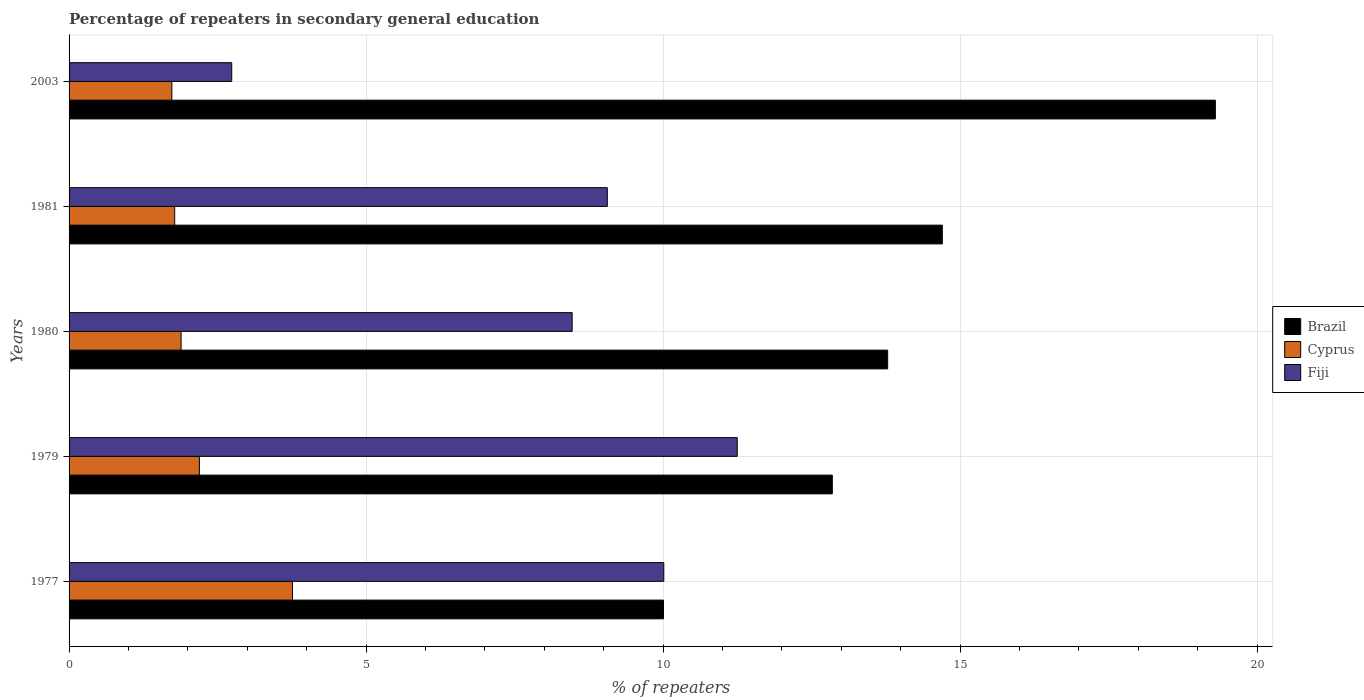Are the number of bars on each tick of the Y-axis equal?
Your response must be concise. Yes. How many bars are there on the 2nd tick from the top?
Keep it short and to the point. 3. How many bars are there on the 1st tick from the bottom?
Offer a very short reply. 3. In how many cases, is the number of bars for a given year not equal to the number of legend labels?
Make the answer very short. 0. What is the percentage of repeaters in secondary general education in Fiji in 1980?
Keep it short and to the point. 8.47. Across all years, what is the maximum percentage of repeaters in secondary general education in Brazil?
Offer a very short reply. 19.3. Across all years, what is the minimum percentage of repeaters in secondary general education in Fiji?
Offer a very short reply. 2.74. In which year was the percentage of repeaters in secondary general education in Fiji maximum?
Your answer should be compact. 1979. In which year was the percentage of repeaters in secondary general education in Fiji minimum?
Keep it short and to the point. 2003. What is the total percentage of repeaters in secondary general education in Cyprus in the graph?
Provide a short and direct response. 11.35. What is the difference between the percentage of repeaters in secondary general education in Cyprus in 1977 and that in 1980?
Ensure brevity in your answer.  1.88. What is the difference between the percentage of repeaters in secondary general education in Fiji in 1980 and the percentage of repeaters in secondary general education in Brazil in 2003?
Make the answer very short. -10.83. What is the average percentage of repeaters in secondary general education in Fiji per year?
Your answer should be compact. 8.31. In the year 2003, what is the difference between the percentage of repeaters in secondary general education in Cyprus and percentage of repeaters in secondary general education in Fiji?
Offer a very short reply. -1.01. What is the ratio of the percentage of repeaters in secondary general education in Fiji in 1977 to that in 2003?
Provide a succinct answer. 3.66. Is the difference between the percentage of repeaters in secondary general education in Cyprus in 1980 and 1981 greater than the difference between the percentage of repeaters in secondary general education in Fiji in 1980 and 1981?
Keep it short and to the point. Yes. What is the difference between the highest and the second highest percentage of repeaters in secondary general education in Fiji?
Give a very brief answer. 1.24. What is the difference between the highest and the lowest percentage of repeaters in secondary general education in Fiji?
Provide a short and direct response. 8.51. Is the sum of the percentage of repeaters in secondary general education in Cyprus in 1981 and 2003 greater than the maximum percentage of repeaters in secondary general education in Brazil across all years?
Your answer should be compact. No. What does the 1st bar from the top in 1980 represents?
Provide a short and direct response. Fiji. What does the 1st bar from the bottom in 1981 represents?
Make the answer very short. Brazil. How many years are there in the graph?
Provide a short and direct response. 5. What is the difference between two consecutive major ticks on the X-axis?
Your response must be concise. 5. Are the values on the major ticks of X-axis written in scientific E-notation?
Your response must be concise. No. Does the graph contain grids?
Provide a succinct answer. Yes. Where does the legend appear in the graph?
Offer a very short reply. Center right. How are the legend labels stacked?
Keep it short and to the point. Vertical. What is the title of the graph?
Give a very brief answer. Percentage of repeaters in secondary general education. Does "Dominican Republic" appear as one of the legend labels in the graph?
Your answer should be very brief. No. What is the label or title of the X-axis?
Offer a very short reply. % of repeaters. What is the label or title of the Y-axis?
Keep it short and to the point. Years. What is the % of repeaters in Brazil in 1977?
Offer a terse response. 10.01. What is the % of repeaters in Cyprus in 1977?
Offer a terse response. 3.76. What is the % of repeaters of Fiji in 1977?
Provide a short and direct response. 10.01. What is the % of repeaters of Brazil in 1979?
Make the answer very short. 12.85. What is the % of repeaters in Cyprus in 1979?
Your response must be concise. 2.19. What is the % of repeaters in Fiji in 1979?
Your answer should be compact. 11.25. What is the % of repeaters of Brazil in 1980?
Provide a short and direct response. 13.78. What is the % of repeaters in Cyprus in 1980?
Provide a succinct answer. 1.89. What is the % of repeaters of Fiji in 1980?
Provide a short and direct response. 8.47. What is the % of repeaters of Brazil in 1981?
Give a very brief answer. 14.7. What is the % of repeaters of Cyprus in 1981?
Your answer should be compact. 1.78. What is the % of repeaters of Fiji in 1981?
Offer a terse response. 9.06. What is the % of repeaters in Brazil in 2003?
Provide a short and direct response. 19.3. What is the % of repeaters in Cyprus in 2003?
Offer a very short reply. 1.73. What is the % of repeaters in Fiji in 2003?
Give a very brief answer. 2.74. Across all years, what is the maximum % of repeaters in Brazil?
Your answer should be compact. 19.3. Across all years, what is the maximum % of repeaters of Cyprus?
Provide a short and direct response. 3.76. Across all years, what is the maximum % of repeaters in Fiji?
Provide a succinct answer. 11.25. Across all years, what is the minimum % of repeaters of Brazil?
Ensure brevity in your answer.  10.01. Across all years, what is the minimum % of repeaters of Cyprus?
Your response must be concise. 1.73. Across all years, what is the minimum % of repeaters in Fiji?
Your answer should be compact. 2.74. What is the total % of repeaters of Brazil in the graph?
Your answer should be very brief. 70.63. What is the total % of repeaters of Cyprus in the graph?
Offer a very short reply. 11.35. What is the total % of repeaters of Fiji in the graph?
Make the answer very short. 41.53. What is the difference between the % of repeaters of Brazil in 1977 and that in 1979?
Your answer should be compact. -2.84. What is the difference between the % of repeaters of Cyprus in 1977 and that in 1979?
Offer a terse response. 1.57. What is the difference between the % of repeaters in Fiji in 1977 and that in 1979?
Offer a terse response. -1.24. What is the difference between the % of repeaters of Brazil in 1977 and that in 1980?
Your response must be concise. -3.77. What is the difference between the % of repeaters of Cyprus in 1977 and that in 1980?
Offer a terse response. 1.88. What is the difference between the % of repeaters of Fiji in 1977 and that in 1980?
Your answer should be very brief. 1.54. What is the difference between the % of repeaters in Brazil in 1977 and that in 1981?
Offer a very short reply. -4.69. What is the difference between the % of repeaters in Cyprus in 1977 and that in 1981?
Your answer should be compact. 1.98. What is the difference between the % of repeaters of Fiji in 1977 and that in 1981?
Offer a very short reply. 0.95. What is the difference between the % of repeaters of Brazil in 1977 and that in 2003?
Give a very brief answer. -9.29. What is the difference between the % of repeaters of Cyprus in 1977 and that in 2003?
Provide a short and direct response. 2.03. What is the difference between the % of repeaters of Fiji in 1977 and that in 2003?
Offer a terse response. 7.27. What is the difference between the % of repeaters in Brazil in 1979 and that in 1980?
Offer a terse response. -0.93. What is the difference between the % of repeaters of Cyprus in 1979 and that in 1980?
Your answer should be very brief. 0.31. What is the difference between the % of repeaters in Fiji in 1979 and that in 1980?
Make the answer very short. 2.78. What is the difference between the % of repeaters of Brazil in 1979 and that in 1981?
Provide a short and direct response. -1.85. What is the difference between the % of repeaters of Cyprus in 1979 and that in 1981?
Your response must be concise. 0.42. What is the difference between the % of repeaters of Fiji in 1979 and that in 1981?
Make the answer very short. 2.19. What is the difference between the % of repeaters in Brazil in 1979 and that in 2003?
Ensure brevity in your answer.  -6.45. What is the difference between the % of repeaters in Cyprus in 1979 and that in 2003?
Provide a succinct answer. 0.46. What is the difference between the % of repeaters in Fiji in 1979 and that in 2003?
Your response must be concise. 8.51. What is the difference between the % of repeaters in Brazil in 1980 and that in 1981?
Your response must be concise. -0.92. What is the difference between the % of repeaters in Cyprus in 1980 and that in 1981?
Provide a short and direct response. 0.11. What is the difference between the % of repeaters of Fiji in 1980 and that in 1981?
Offer a very short reply. -0.59. What is the difference between the % of repeaters of Brazil in 1980 and that in 2003?
Your answer should be compact. -5.52. What is the difference between the % of repeaters in Cyprus in 1980 and that in 2003?
Offer a very short reply. 0.16. What is the difference between the % of repeaters of Fiji in 1980 and that in 2003?
Offer a very short reply. 5.73. What is the difference between the % of repeaters in Brazil in 1981 and that in 2003?
Your answer should be compact. -4.6. What is the difference between the % of repeaters in Cyprus in 1981 and that in 2003?
Provide a succinct answer. 0.05. What is the difference between the % of repeaters in Fiji in 1981 and that in 2003?
Provide a short and direct response. 6.32. What is the difference between the % of repeaters in Brazil in 1977 and the % of repeaters in Cyprus in 1979?
Offer a terse response. 7.81. What is the difference between the % of repeaters in Brazil in 1977 and the % of repeaters in Fiji in 1979?
Your response must be concise. -1.24. What is the difference between the % of repeaters in Cyprus in 1977 and the % of repeaters in Fiji in 1979?
Provide a short and direct response. -7.49. What is the difference between the % of repeaters in Brazil in 1977 and the % of repeaters in Cyprus in 1980?
Keep it short and to the point. 8.12. What is the difference between the % of repeaters of Brazil in 1977 and the % of repeaters of Fiji in 1980?
Your answer should be very brief. 1.54. What is the difference between the % of repeaters in Cyprus in 1977 and the % of repeaters in Fiji in 1980?
Provide a succinct answer. -4.71. What is the difference between the % of repeaters in Brazil in 1977 and the % of repeaters in Cyprus in 1981?
Offer a terse response. 8.23. What is the difference between the % of repeaters of Brazil in 1977 and the % of repeaters of Fiji in 1981?
Provide a short and direct response. 0.95. What is the difference between the % of repeaters in Cyprus in 1977 and the % of repeaters in Fiji in 1981?
Provide a succinct answer. -5.3. What is the difference between the % of repeaters in Brazil in 1977 and the % of repeaters in Cyprus in 2003?
Your answer should be compact. 8.28. What is the difference between the % of repeaters of Brazil in 1977 and the % of repeaters of Fiji in 2003?
Give a very brief answer. 7.27. What is the difference between the % of repeaters in Cyprus in 1977 and the % of repeaters in Fiji in 2003?
Offer a very short reply. 1.02. What is the difference between the % of repeaters of Brazil in 1979 and the % of repeaters of Cyprus in 1980?
Provide a succinct answer. 10.96. What is the difference between the % of repeaters of Brazil in 1979 and the % of repeaters of Fiji in 1980?
Keep it short and to the point. 4.38. What is the difference between the % of repeaters in Cyprus in 1979 and the % of repeaters in Fiji in 1980?
Give a very brief answer. -6.28. What is the difference between the % of repeaters in Brazil in 1979 and the % of repeaters in Cyprus in 1981?
Offer a terse response. 11.07. What is the difference between the % of repeaters in Brazil in 1979 and the % of repeaters in Fiji in 1981?
Give a very brief answer. 3.79. What is the difference between the % of repeaters in Cyprus in 1979 and the % of repeaters in Fiji in 1981?
Offer a very short reply. -6.87. What is the difference between the % of repeaters of Brazil in 1979 and the % of repeaters of Cyprus in 2003?
Offer a very short reply. 11.12. What is the difference between the % of repeaters in Brazil in 1979 and the % of repeaters in Fiji in 2003?
Provide a succinct answer. 10.11. What is the difference between the % of repeaters in Cyprus in 1979 and the % of repeaters in Fiji in 2003?
Your answer should be compact. -0.54. What is the difference between the % of repeaters in Brazil in 1980 and the % of repeaters in Cyprus in 1981?
Keep it short and to the point. 12. What is the difference between the % of repeaters in Brazil in 1980 and the % of repeaters in Fiji in 1981?
Offer a terse response. 4.72. What is the difference between the % of repeaters of Cyprus in 1980 and the % of repeaters of Fiji in 1981?
Offer a terse response. -7.17. What is the difference between the % of repeaters in Brazil in 1980 and the % of repeaters in Cyprus in 2003?
Make the answer very short. 12.05. What is the difference between the % of repeaters of Brazil in 1980 and the % of repeaters of Fiji in 2003?
Provide a short and direct response. 11.04. What is the difference between the % of repeaters in Cyprus in 1980 and the % of repeaters in Fiji in 2003?
Keep it short and to the point. -0.85. What is the difference between the % of repeaters in Brazil in 1981 and the % of repeaters in Cyprus in 2003?
Provide a succinct answer. 12.97. What is the difference between the % of repeaters in Brazil in 1981 and the % of repeaters in Fiji in 2003?
Offer a terse response. 11.96. What is the difference between the % of repeaters in Cyprus in 1981 and the % of repeaters in Fiji in 2003?
Your answer should be compact. -0.96. What is the average % of repeaters in Brazil per year?
Provide a succinct answer. 14.13. What is the average % of repeaters in Cyprus per year?
Offer a terse response. 2.27. What is the average % of repeaters of Fiji per year?
Your response must be concise. 8.31. In the year 1977, what is the difference between the % of repeaters of Brazil and % of repeaters of Cyprus?
Provide a succinct answer. 6.25. In the year 1977, what is the difference between the % of repeaters in Brazil and % of repeaters in Fiji?
Make the answer very short. -0.01. In the year 1977, what is the difference between the % of repeaters of Cyprus and % of repeaters of Fiji?
Offer a terse response. -6.25. In the year 1979, what is the difference between the % of repeaters in Brazil and % of repeaters in Cyprus?
Provide a succinct answer. 10.65. In the year 1979, what is the difference between the % of repeaters of Brazil and % of repeaters of Fiji?
Give a very brief answer. 1.6. In the year 1979, what is the difference between the % of repeaters in Cyprus and % of repeaters in Fiji?
Make the answer very short. -9.05. In the year 1980, what is the difference between the % of repeaters of Brazil and % of repeaters of Cyprus?
Provide a short and direct response. 11.89. In the year 1980, what is the difference between the % of repeaters of Brazil and % of repeaters of Fiji?
Keep it short and to the point. 5.31. In the year 1980, what is the difference between the % of repeaters in Cyprus and % of repeaters in Fiji?
Make the answer very short. -6.58. In the year 1981, what is the difference between the % of repeaters of Brazil and % of repeaters of Cyprus?
Offer a very short reply. 12.92. In the year 1981, what is the difference between the % of repeaters of Brazil and % of repeaters of Fiji?
Ensure brevity in your answer.  5.64. In the year 1981, what is the difference between the % of repeaters in Cyprus and % of repeaters in Fiji?
Give a very brief answer. -7.28. In the year 2003, what is the difference between the % of repeaters in Brazil and % of repeaters in Cyprus?
Ensure brevity in your answer.  17.57. In the year 2003, what is the difference between the % of repeaters in Brazil and % of repeaters in Fiji?
Keep it short and to the point. 16.56. In the year 2003, what is the difference between the % of repeaters of Cyprus and % of repeaters of Fiji?
Give a very brief answer. -1.01. What is the ratio of the % of repeaters of Brazil in 1977 to that in 1979?
Provide a short and direct response. 0.78. What is the ratio of the % of repeaters of Cyprus in 1977 to that in 1979?
Offer a very short reply. 1.71. What is the ratio of the % of repeaters of Fiji in 1977 to that in 1979?
Ensure brevity in your answer.  0.89. What is the ratio of the % of repeaters in Brazil in 1977 to that in 1980?
Provide a succinct answer. 0.73. What is the ratio of the % of repeaters in Cyprus in 1977 to that in 1980?
Offer a very short reply. 1.99. What is the ratio of the % of repeaters of Fiji in 1977 to that in 1980?
Provide a short and direct response. 1.18. What is the ratio of the % of repeaters in Brazil in 1977 to that in 1981?
Offer a very short reply. 0.68. What is the ratio of the % of repeaters in Cyprus in 1977 to that in 1981?
Keep it short and to the point. 2.12. What is the ratio of the % of repeaters of Fiji in 1977 to that in 1981?
Offer a terse response. 1.1. What is the ratio of the % of repeaters in Brazil in 1977 to that in 2003?
Your answer should be compact. 0.52. What is the ratio of the % of repeaters of Cyprus in 1977 to that in 2003?
Provide a succinct answer. 2.17. What is the ratio of the % of repeaters in Fiji in 1977 to that in 2003?
Make the answer very short. 3.66. What is the ratio of the % of repeaters of Brazil in 1979 to that in 1980?
Give a very brief answer. 0.93. What is the ratio of the % of repeaters of Cyprus in 1979 to that in 1980?
Keep it short and to the point. 1.16. What is the ratio of the % of repeaters in Fiji in 1979 to that in 1980?
Offer a terse response. 1.33. What is the ratio of the % of repeaters of Brazil in 1979 to that in 1981?
Your answer should be compact. 0.87. What is the ratio of the % of repeaters in Cyprus in 1979 to that in 1981?
Ensure brevity in your answer.  1.23. What is the ratio of the % of repeaters in Fiji in 1979 to that in 1981?
Your answer should be very brief. 1.24. What is the ratio of the % of repeaters in Brazil in 1979 to that in 2003?
Your response must be concise. 0.67. What is the ratio of the % of repeaters of Cyprus in 1979 to that in 2003?
Offer a terse response. 1.27. What is the ratio of the % of repeaters in Fiji in 1979 to that in 2003?
Your answer should be compact. 4.11. What is the ratio of the % of repeaters of Brazil in 1980 to that in 1981?
Offer a terse response. 0.94. What is the ratio of the % of repeaters of Cyprus in 1980 to that in 1981?
Give a very brief answer. 1.06. What is the ratio of the % of repeaters in Fiji in 1980 to that in 1981?
Provide a short and direct response. 0.93. What is the ratio of the % of repeaters in Brazil in 1980 to that in 2003?
Offer a very short reply. 0.71. What is the ratio of the % of repeaters in Cyprus in 1980 to that in 2003?
Your answer should be very brief. 1.09. What is the ratio of the % of repeaters in Fiji in 1980 to that in 2003?
Make the answer very short. 3.09. What is the ratio of the % of repeaters of Brazil in 1981 to that in 2003?
Ensure brevity in your answer.  0.76. What is the ratio of the % of repeaters of Cyprus in 1981 to that in 2003?
Offer a terse response. 1.03. What is the ratio of the % of repeaters of Fiji in 1981 to that in 2003?
Provide a short and direct response. 3.31. What is the difference between the highest and the second highest % of repeaters in Brazil?
Offer a terse response. 4.6. What is the difference between the highest and the second highest % of repeaters in Cyprus?
Ensure brevity in your answer.  1.57. What is the difference between the highest and the second highest % of repeaters of Fiji?
Your response must be concise. 1.24. What is the difference between the highest and the lowest % of repeaters in Brazil?
Keep it short and to the point. 9.29. What is the difference between the highest and the lowest % of repeaters of Cyprus?
Give a very brief answer. 2.03. What is the difference between the highest and the lowest % of repeaters in Fiji?
Ensure brevity in your answer.  8.51. 